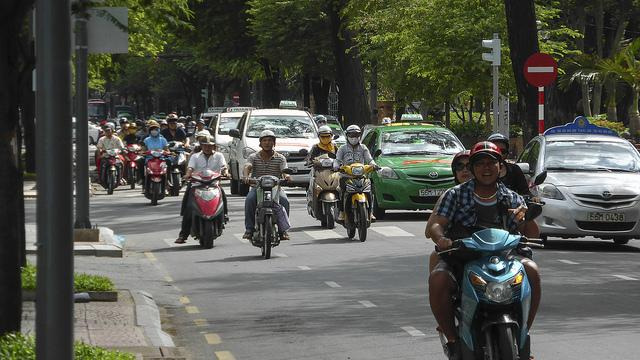How many directions does traffic flow in these pictured lanes?

Choices:
A) two
B) none
C) three
D) one one 